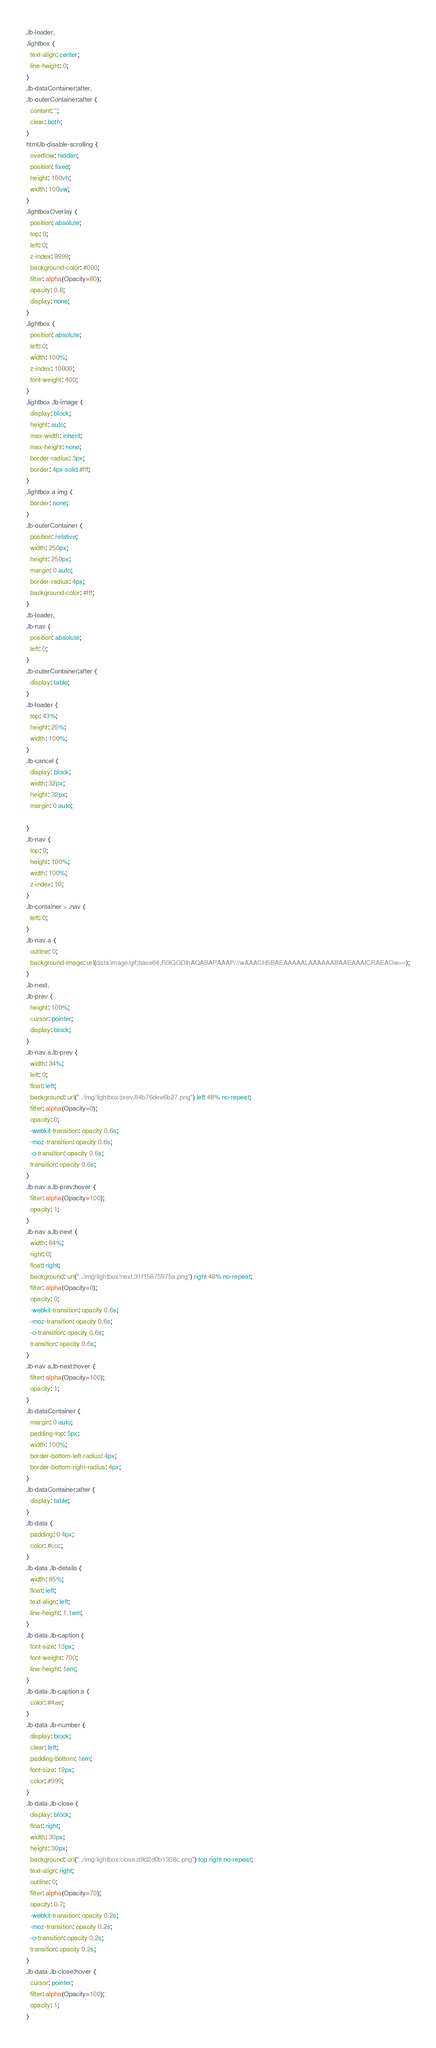Convert code to text. <code><loc_0><loc_0><loc_500><loc_500><_CSS_>.lb-loader,
.lightbox {
  text-align: center;
  line-height: 0;
}
.lb-dataContainer:after,
.lb-outerContainer:after {
  content: '';
  clear: both;
}
html.lb-disable-scrolling {
  overflow: hidden;
  position: fixed;
  height: 100vh;
  width: 100vw;
}
.lightboxOverlay {
  position: absolute;
  top: 0;
  left: 0;
  z-index: 9999;
  background-color: #000;
  filter: alpha(Opacity=80);
  opacity: 0.8;
  display: none;
}
.lightbox {
  position: absolute;
  left: 0;
  width: 100%;
  z-index: 10000;
  font-weight: 400;
}
.lightbox .lb-image {
  display: block;
  height: auto;
  max-width: inherit;
  max-height: none;
  border-radius: 3px;
  border: 4px solid #fff;
}
.lightbox a img {
  border: none;
}
.lb-outerContainer {
  position: relative;
  width: 250px;
  height: 250px;
  margin: 0 auto;
  border-radius: 4px;
  background-color: #fff;
}
.lb-loader,
.lb-nav {
  position: absolute;
  left: 0;
}
.lb-outerContainer:after {
  display: table;
}
.lb-loader {
  top: 43%;
  height: 25%;
  width: 100%;
}
.lb-cancel {
  display: block;
  width: 32px;
  height: 32px;
  margin: 0 auto;

}
.lb-nav {
  top: 0;
  height: 100%;
  width: 100%;
  z-index: 10;
}
.lb-container > .nav {
  left: 0;
}
.lb-nav a {
  outline: 0;
  background-image: url(data:image/gif;base64,R0lGODlhAQABAPAAAP///wAAACH5BAEAAAAALAAAAAABAAEAAAICRAEAOw==);
}
.lb-next,
.lb-prev {
  height: 100%;
  cursor: pointer;
  display: block;
}
.lb-nav a.lb-prev {
  width: 34%;
  left: 0;
  float: left;
  background: url("../img/lightbox/prev.84b76dee6b27.png") left 48% no-repeat;
  filter: alpha(Opacity=0);
  opacity: 0;
  -webkit-transition: opacity 0.6s;
  -moz-transition: opacity 0.6s;
  -o-transition: opacity 0.6s;
  transition: opacity 0.6s;
}
.lb-nav a.lb-prev:hover {
  filter: alpha(Opacity=100);
  opacity: 1;
}
.lb-nav a.lb-next {
  width: 64%;
  right: 0;
  float: right;
  background: url("../img/lightbox/next.31f15875975a.png") right 48% no-repeat;
  filter: alpha(Opacity=0);
  opacity: 0;
  -webkit-transition: opacity 0.6s;
  -moz-transition: opacity 0.6s;
  -o-transition: opacity 0.6s;
  transition: opacity 0.6s;
}
.lb-nav a.lb-next:hover {
  filter: alpha(Opacity=100);
  opacity: 1;
}
.lb-dataContainer {
  margin: 0 auto;
  padding-top: 5px;
  width: 100%;
  border-bottom-left-radius: 4px;
  border-bottom-right-radius: 4px;
}
.lb-dataContainer:after {
  display: table;
}
.lb-data {
  padding: 0 4px;
  color: #ccc;
}
.lb-data .lb-details {
  width: 85%;
  float: left;
  text-align: left;
  line-height: 1.1em;
}
.lb-data .lb-caption {
  font-size: 13px;
  font-weight: 700;
  line-height: 1em;
}
.lb-data .lb-caption a {
  color: #4ae;
}
.lb-data .lb-number {
  display: block;
  clear: left;
  padding-bottom: 1em;
  font-size: 12px;
  color: #999;
}
.lb-data .lb-close {
  display: block;
  float: right;
  width: 30px;
  height: 30px;
  background: url("../img/lightbox/close.d9d2d0b1308c.png") top right no-repeat;
  text-align: right;
  outline: 0;
  filter: alpha(Opacity=70);
  opacity: 0.7;
  -webkit-transition: opacity 0.2s;
  -moz-transition: opacity 0.2s;
  -o-transition: opacity 0.2s;
  transition: opacity 0.2s;
}
.lb-data .lb-close:hover {
  cursor: pointer;
  filter: alpha(Opacity=100);
  opacity: 1;
}
</code> 